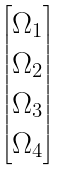Convert formula to latex. <formula><loc_0><loc_0><loc_500><loc_500>\begin{bmatrix} \Omega _ { 1 } \\ \Omega _ { 2 } \\ \Omega _ { 3 } \\ \Omega _ { 4 } \end{bmatrix}</formula> 